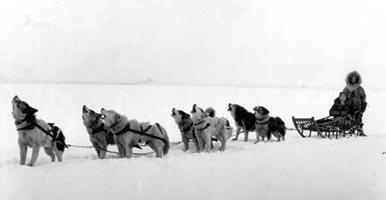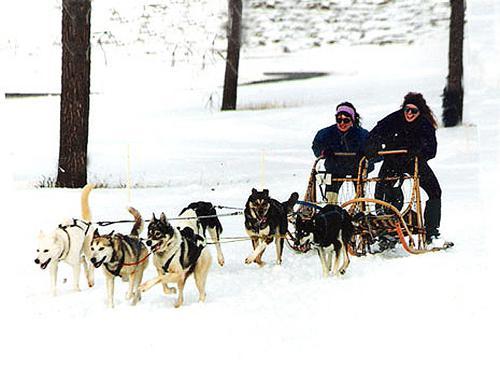The first image is the image on the left, the second image is the image on the right. Assess this claim about the two images: "The dog sled teams in the left and right images are moving forward and are angled so they head toward each other.". Correct or not? Answer yes or no. No. 